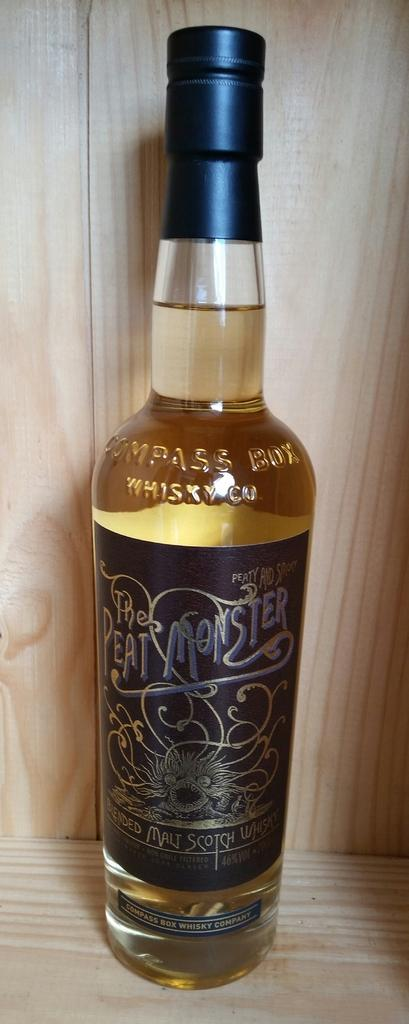<image>
Create a compact narrative representing the image presented. A bottle labelled Peat Monster full of a yellowish liquid. 